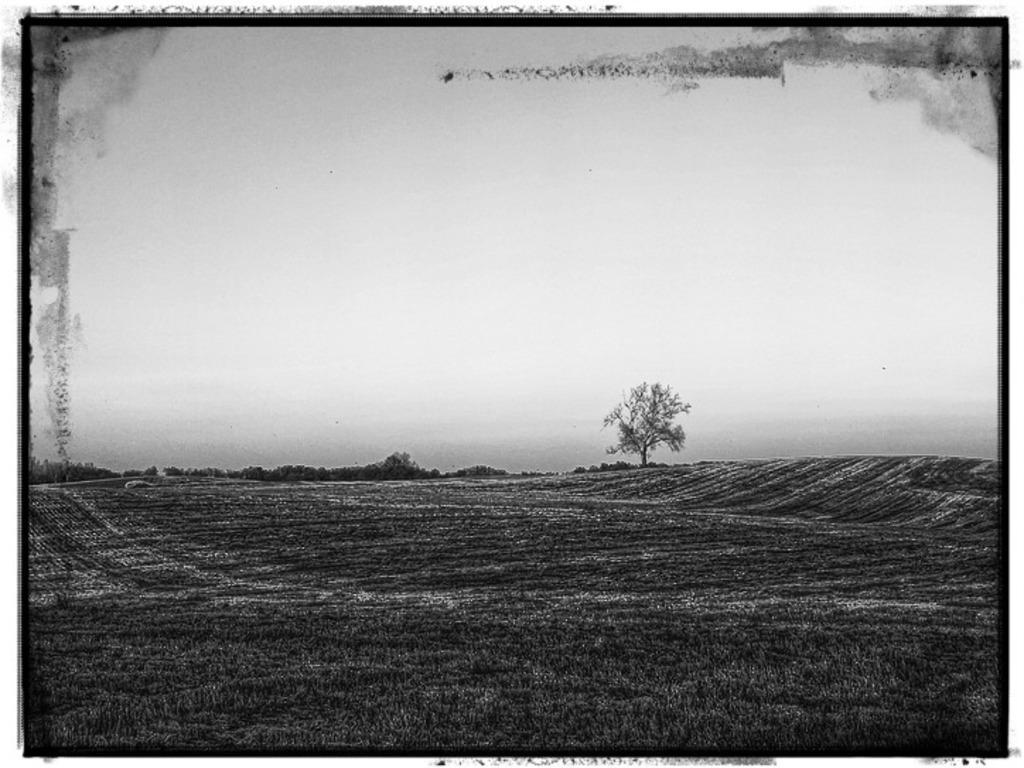Please provide a concise description of this image. This is a black and white image. There is a tree in the middle. There is grass at the bottom. 